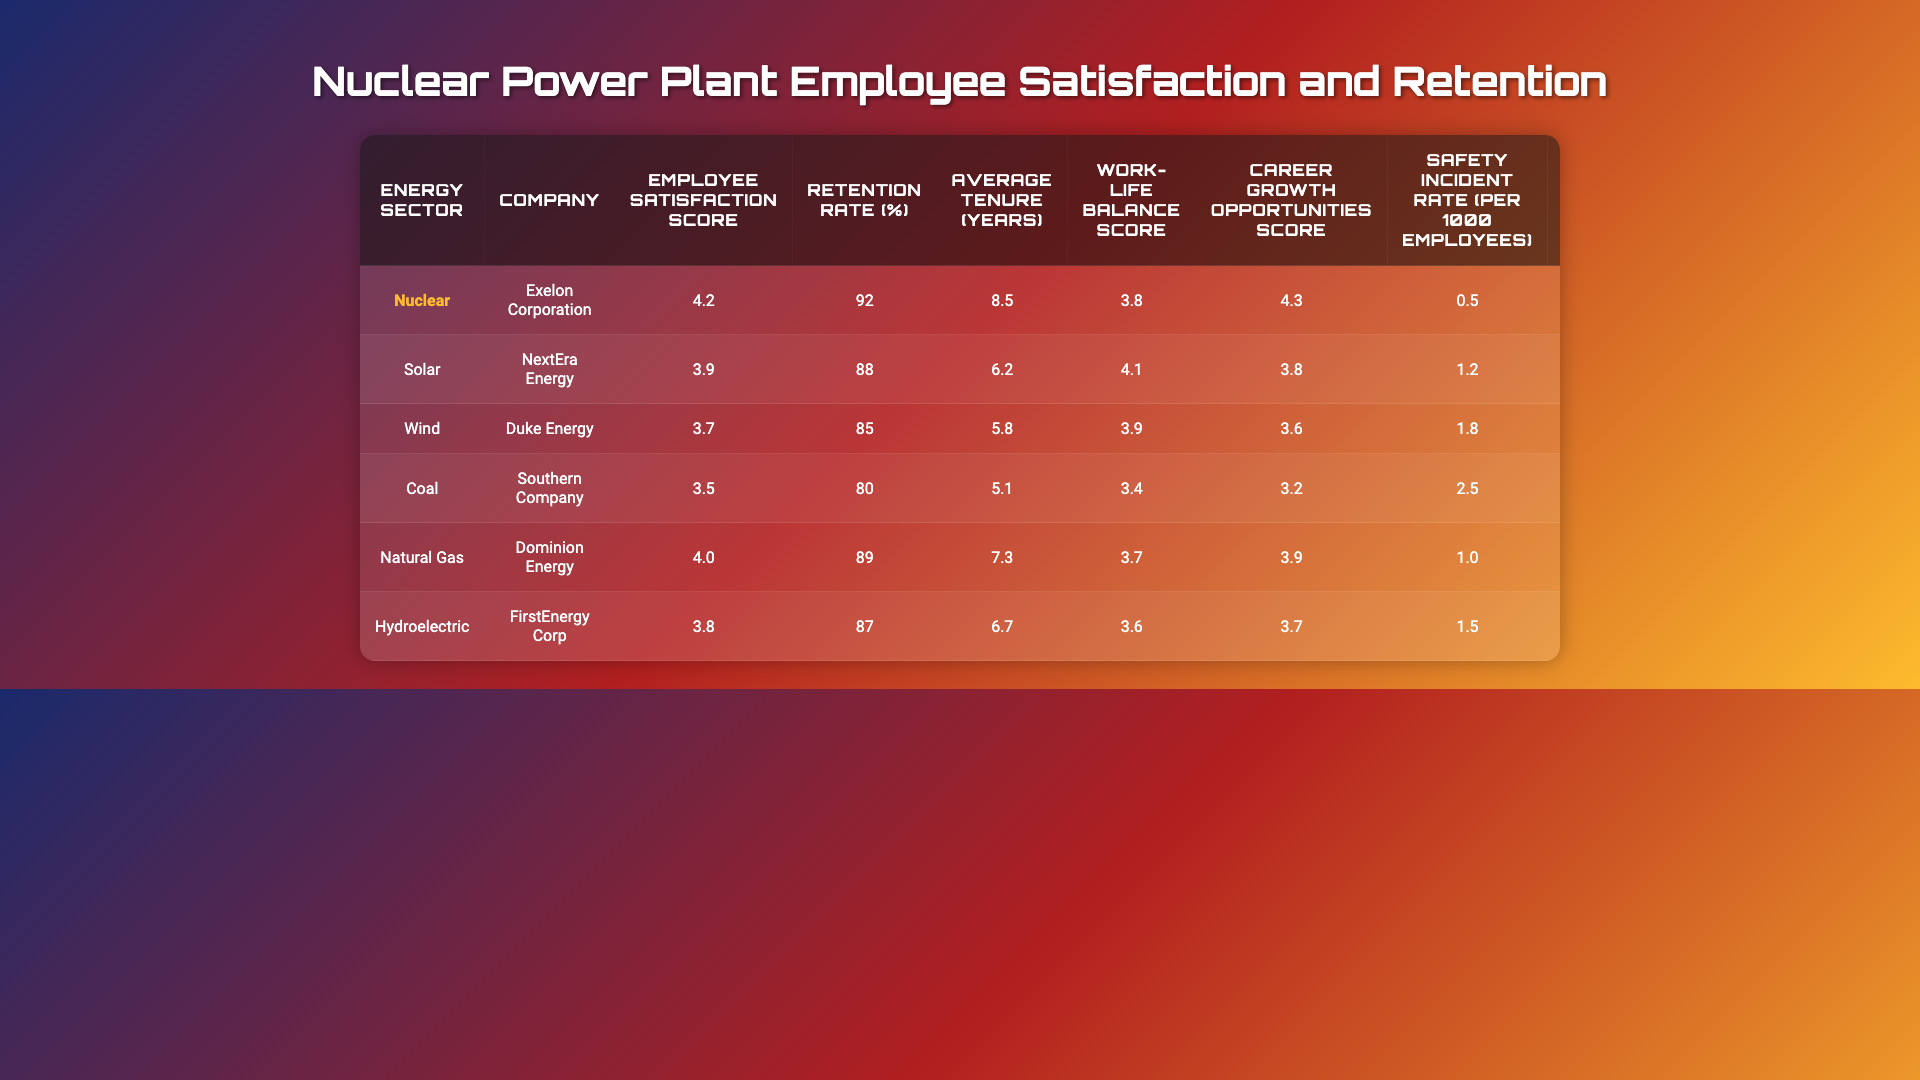What is the employee satisfaction score for the Nuclear sector? The employee satisfaction score for the Nuclear sector is listed in the table under the "Employee Satisfaction Score" column, which shows a value of 4.2.
Answer: 4.2 Which energy sector has the highest retention rate? By comparing the retention rates in the "Retention Rate (%)" column, the Nuclear sector has the highest retention rate at 92%, more than any other listed sector.
Answer: Nuclear What is the average tenure in years for employees in the Wind sector? The average tenure for the Wind sector is directly available in the table under the "Average Tenure (years)" column, which shows a value of 5.8 years.
Answer: 5.8 How does the employee engagement score of the Solar sector compare to the Nuclear sector? The employee engagement score for the Solar sector is 3.7 and for the Nuclear sector, it is 4.1. Comparing these, the Nuclear sector has a higher engagement score.
Answer: Nuclear sector is higher What is the turnover rate for the Coal sector? The turnover rate for the Coal sector is found in the "Turnover Rate (%)" column, showing a value of 20%.
Answer: 20% What is the difference in training hours per employee annually between the Nuclear and Natural Gas sectors? The Nuclear sector has 120 training hours annually, while the Natural Gas sector has 90. The difference can be calculated as 120 - 90 = 30 hours.
Answer: 30 hours Are training hours per employee highest in the Nuclear sector? Looking at the training hours across all sectors, Nuclear has the highest at 120 hours compared to the other sectors which have 80, 70, 60, 90, and 85 hours. Thus, it can be confirmed that the Nuclear sector has the highest training hours.
Answer: Yes What is the median score for career growth opportunities across all sectors? To find the median, first, the scores are organized: 3.2, 3.6, 3.7, 3.8, 3.9, 4.3. There are 6 scores, so the median is the average of the 3rd and 4th values (3.7 and 3.8), which is (3.7 + 3.8) / 2 = 3.75.
Answer: 3.75 Which sector has the highest safety incident rate per 1000 employees? The safety incident rates can be found in the "Safety Incident Rate (per 1000 employees)" column, where the Coal sector has the highest value of 2.5 incidents per 1000 employees.
Answer: Coal What is the average employee satisfaction score across all sectors? The average can be calculated by adding all scores: (4.2 + 3.9 + 3.7 + 3.5 + 4.0 + 3.8) = 23.1, and dividing by 6 gives 23.1 / 6 = 3.85.
Answer: 3.85 Which energy sector has the best work-life balance score? The work-life balance scores in the table show that the Solar sector has the highest score of 4.1, which is higher than the scores of other sectors.
Answer: Solar 